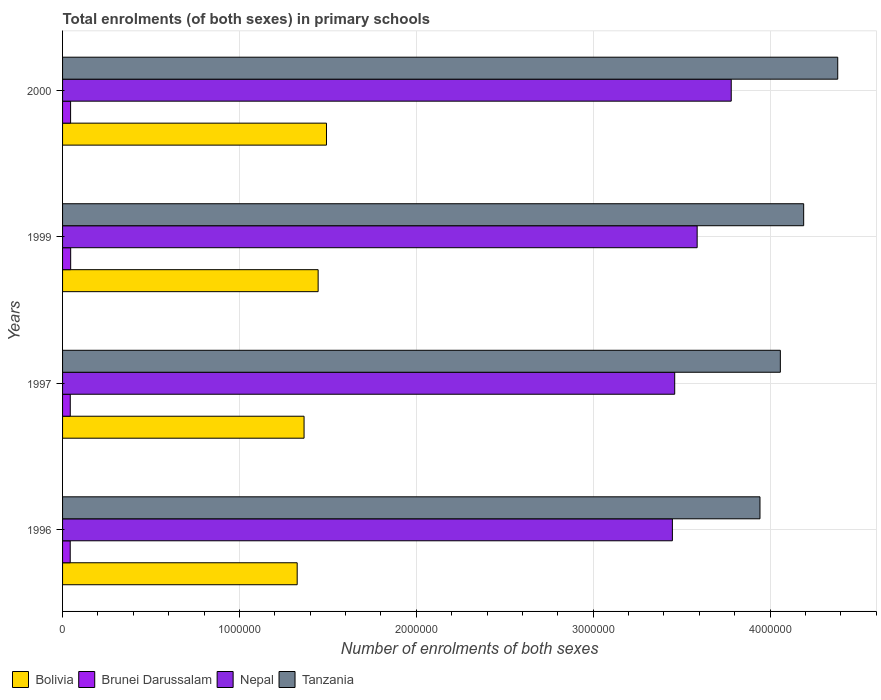How many bars are there on the 2nd tick from the bottom?
Ensure brevity in your answer.  4. What is the label of the 2nd group of bars from the top?
Keep it short and to the point. 1999. What is the number of enrolments in primary schools in Nepal in 1997?
Give a very brief answer. 3.46e+06. Across all years, what is the maximum number of enrolments in primary schools in Bolivia?
Your answer should be compact. 1.49e+06. Across all years, what is the minimum number of enrolments in primary schools in Nepal?
Ensure brevity in your answer.  3.45e+06. What is the total number of enrolments in primary schools in Nepal in the graph?
Offer a terse response. 1.43e+07. What is the difference between the number of enrolments in primary schools in Brunei Darussalam in 1996 and that in 1999?
Your answer should be very brief. -2536. What is the difference between the number of enrolments in primary schools in Brunei Darussalam in 1996 and the number of enrolments in primary schools in Bolivia in 1997?
Your response must be concise. -1.32e+06. What is the average number of enrolments in primary schools in Nepal per year?
Provide a succinct answer. 3.57e+06. In the year 1996, what is the difference between the number of enrolments in primary schools in Nepal and number of enrolments in primary schools in Bolivia?
Offer a very short reply. 2.12e+06. In how many years, is the number of enrolments in primary schools in Tanzania greater than 4000000 ?
Keep it short and to the point. 3. What is the ratio of the number of enrolments in primary schools in Tanzania in 1997 to that in 2000?
Offer a terse response. 0.93. What is the difference between the highest and the second highest number of enrolments in primary schools in Nepal?
Your answer should be compact. 1.93e+05. What is the difference between the highest and the lowest number of enrolments in primary schools in Nepal?
Provide a short and direct response. 3.33e+05. In how many years, is the number of enrolments in primary schools in Tanzania greater than the average number of enrolments in primary schools in Tanzania taken over all years?
Keep it short and to the point. 2. Is the sum of the number of enrolments in primary schools in Tanzania in 1996 and 2000 greater than the maximum number of enrolments in primary schools in Bolivia across all years?
Ensure brevity in your answer.  Yes. Is it the case that in every year, the sum of the number of enrolments in primary schools in Brunei Darussalam and number of enrolments in primary schools in Nepal is greater than the sum of number of enrolments in primary schools in Bolivia and number of enrolments in primary schools in Tanzania?
Offer a very short reply. Yes. What does the 1st bar from the top in 2000 represents?
Your response must be concise. Tanzania. What does the 3rd bar from the bottom in 1997 represents?
Offer a very short reply. Nepal. Are all the bars in the graph horizontal?
Offer a terse response. Yes. How many years are there in the graph?
Make the answer very short. 4. Are the values on the major ticks of X-axis written in scientific E-notation?
Offer a terse response. No. Does the graph contain grids?
Your answer should be very brief. Yes. Where does the legend appear in the graph?
Provide a short and direct response. Bottom left. How are the legend labels stacked?
Give a very brief answer. Horizontal. What is the title of the graph?
Give a very brief answer. Total enrolments (of both sexes) in primary schools. Does "Small states" appear as one of the legend labels in the graph?
Offer a terse response. No. What is the label or title of the X-axis?
Give a very brief answer. Number of enrolments of both sexes. What is the label or title of the Y-axis?
Make the answer very short. Years. What is the Number of enrolments of both sexes of Bolivia in 1996?
Offer a very short reply. 1.33e+06. What is the Number of enrolments of both sexes of Brunei Darussalam in 1996?
Your response must be concise. 4.33e+04. What is the Number of enrolments of both sexes in Nepal in 1996?
Offer a very short reply. 3.45e+06. What is the Number of enrolments of both sexes of Tanzania in 1996?
Provide a succinct answer. 3.94e+06. What is the Number of enrolments of both sexes of Bolivia in 1997?
Ensure brevity in your answer.  1.37e+06. What is the Number of enrolments of both sexes in Brunei Darussalam in 1997?
Ensure brevity in your answer.  4.35e+04. What is the Number of enrolments of both sexes in Nepal in 1997?
Give a very brief answer. 3.46e+06. What is the Number of enrolments of both sexes in Tanzania in 1997?
Your answer should be compact. 4.06e+06. What is the Number of enrolments of both sexes of Bolivia in 1999?
Offer a terse response. 1.44e+06. What is the Number of enrolments of both sexes of Brunei Darussalam in 1999?
Offer a terse response. 4.58e+04. What is the Number of enrolments of both sexes in Nepal in 1999?
Keep it short and to the point. 3.59e+06. What is the Number of enrolments of both sexes in Tanzania in 1999?
Make the answer very short. 4.19e+06. What is the Number of enrolments of both sexes in Bolivia in 2000?
Keep it short and to the point. 1.49e+06. What is the Number of enrolments of both sexes in Brunei Darussalam in 2000?
Your response must be concise. 4.54e+04. What is the Number of enrolments of both sexes in Nepal in 2000?
Provide a succinct answer. 3.78e+06. What is the Number of enrolments of both sexes in Tanzania in 2000?
Offer a very short reply. 4.38e+06. Across all years, what is the maximum Number of enrolments of both sexes in Bolivia?
Your answer should be very brief. 1.49e+06. Across all years, what is the maximum Number of enrolments of both sexes of Brunei Darussalam?
Ensure brevity in your answer.  4.58e+04. Across all years, what is the maximum Number of enrolments of both sexes in Nepal?
Keep it short and to the point. 3.78e+06. Across all years, what is the maximum Number of enrolments of both sexes in Tanzania?
Your answer should be very brief. 4.38e+06. Across all years, what is the minimum Number of enrolments of both sexes of Bolivia?
Provide a short and direct response. 1.33e+06. Across all years, what is the minimum Number of enrolments of both sexes of Brunei Darussalam?
Ensure brevity in your answer.  4.33e+04. Across all years, what is the minimum Number of enrolments of both sexes of Nepal?
Provide a succinct answer. 3.45e+06. Across all years, what is the minimum Number of enrolments of both sexes of Tanzania?
Ensure brevity in your answer.  3.94e+06. What is the total Number of enrolments of both sexes of Bolivia in the graph?
Provide a succinct answer. 5.63e+06. What is the total Number of enrolments of both sexes in Brunei Darussalam in the graph?
Your answer should be very brief. 1.78e+05. What is the total Number of enrolments of both sexes of Nepal in the graph?
Offer a very short reply. 1.43e+07. What is the total Number of enrolments of both sexes in Tanzania in the graph?
Keep it short and to the point. 1.66e+07. What is the difference between the Number of enrolments of both sexes of Bolivia in 1996 and that in 1997?
Offer a terse response. -3.89e+04. What is the difference between the Number of enrolments of both sexes of Brunei Darussalam in 1996 and that in 1997?
Keep it short and to the point. -249. What is the difference between the Number of enrolments of both sexes in Nepal in 1996 and that in 1997?
Provide a succinct answer. -1.31e+04. What is the difference between the Number of enrolments of both sexes in Tanzania in 1996 and that in 1997?
Your answer should be very brief. -1.15e+05. What is the difference between the Number of enrolments of both sexes of Bolivia in 1996 and that in 1999?
Your answer should be very brief. -1.18e+05. What is the difference between the Number of enrolments of both sexes of Brunei Darussalam in 1996 and that in 1999?
Your answer should be compact. -2536. What is the difference between the Number of enrolments of both sexes of Nepal in 1996 and that in 1999?
Offer a terse response. -1.40e+05. What is the difference between the Number of enrolments of both sexes of Tanzania in 1996 and that in 1999?
Offer a very short reply. -2.47e+05. What is the difference between the Number of enrolments of both sexes in Bolivia in 1996 and that in 2000?
Keep it short and to the point. -1.66e+05. What is the difference between the Number of enrolments of both sexes in Brunei Darussalam in 1996 and that in 2000?
Your answer should be compact. -2137. What is the difference between the Number of enrolments of both sexes of Nepal in 1996 and that in 2000?
Keep it short and to the point. -3.33e+05. What is the difference between the Number of enrolments of both sexes of Tanzania in 1996 and that in 2000?
Offer a terse response. -4.40e+05. What is the difference between the Number of enrolments of both sexes in Bolivia in 1997 and that in 1999?
Your answer should be compact. -7.96e+04. What is the difference between the Number of enrolments of both sexes of Brunei Darussalam in 1997 and that in 1999?
Your response must be concise. -2287. What is the difference between the Number of enrolments of both sexes of Nepal in 1997 and that in 1999?
Keep it short and to the point. -1.27e+05. What is the difference between the Number of enrolments of both sexes in Tanzania in 1997 and that in 1999?
Ensure brevity in your answer.  -1.32e+05. What is the difference between the Number of enrolments of both sexes in Bolivia in 1997 and that in 2000?
Your answer should be compact. -1.27e+05. What is the difference between the Number of enrolments of both sexes of Brunei Darussalam in 1997 and that in 2000?
Offer a very short reply. -1888. What is the difference between the Number of enrolments of both sexes in Nepal in 1997 and that in 2000?
Make the answer very short. -3.20e+05. What is the difference between the Number of enrolments of both sexes in Tanzania in 1997 and that in 2000?
Give a very brief answer. -3.24e+05. What is the difference between the Number of enrolments of both sexes in Bolivia in 1999 and that in 2000?
Your answer should be very brief. -4.71e+04. What is the difference between the Number of enrolments of both sexes of Brunei Darussalam in 1999 and that in 2000?
Your answer should be very brief. 399. What is the difference between the Number of enrolments of both sexes in Nepal in 1999 and that in 2000?
Keep it short and to the point. -1.93e+05. What is the difference between the Number of enrolments of both sexes of Tanzania in 1999 and that in 2000?
Provide a succinct answer. -1.93e+05. What is the difference between the Number of enrolments of both sexes of Bolivia in 1996 and the Number of enrolments of both sexes of Brunei Darussalam in 1997?
Give a very brief answer. 1.28e+06. What is the difference between the Number of enrolments of both sexes of Bolivia in 1996 and the Number of enrolments of both sexes of Nepal in 1997?
Make the answer very short. -2.13e+06. What is the difference between the Number of enrolments of both sexes of Bolivia in 1996 and the Number of enrolments of both sexes of Tanzania in 1997?
Make the answer very short. -2.73e+06. What is the difference between the Number of enrolments of both sexes of Brunei Darussalam in 1996 and the Number of enrolments of both sexes of Nepal in 1997?
Offer a terse response. -3.42e+06. What is the difference between the Number of enrolments of both sexes in Brunei Darussalam in 1996 and the Number of enrolments of both sexes in Tanzania in 1997?
Provide a succinct answer. -4.01e+06. What is the difference between the Number of enrolments of both sexes in Nepal in 1996 and the Number of enrolments of both sexes in Tanzania in 1997?
Provide a succinct answer. -6.10e+05. What is the difference between the Number of enrolments of both sexes of Bolivia in 1996 and the Number of enrolments of both sexes of Brunei Darussalam in 1999?
Offer a very short reply. 1.28e+06. What is the difference between the Number of enrolments of both sexes of Bolivia in 1996 and the Number of enrolments of both sexes of Nepal in 1999?
Your response must be concise. -2.26e+06. What is the difference between the Number of enrolments of both sexes in Bolivia in 1996 and the Number of enrolments of both sexes in Tanzania in 1999?
Provide a succinct answer. -2.86e+06. What is the difference between the Number of enrolments of both sexes of Brunei Darussalam in 1996 and the Number of enrolments of both sexes of Nepal in 1999?
Keep it short and to the point. -3.54e+06. What is the difference between the Number of enrolments of both sexes in Brunei Darussalam in 1996 and the Number of enrolments of both sexes in Tanzania in 1999?
Your answer should be very brief. -4.15e+06. What is the difference between the Number of enrolments of both sexes of Nepal in 1996 and the Number of enrolments of both sexes of Tanzania in 1999?
Your answer should be very brief. -7.42e+05. What is the difference between the Number of enrolments of both sexes in Bolivia in 1996 and the Number of enrolments of both sexes in Brunei Darussalam in 2000?
Your answer should be compact. 1.28e+06. What is the difference between the Number of enrolments of both sexes of Bolivia in 1996 and the Number of enrolments of both sexes of Nepal in 2000?
Keep it short and to the point. -2.45e+06. What is the difference between the Number of enrolments of both sexes of Bolivia in 1996 and the Number of enrolments of both sexes of Tanzania in 2000?
Ensure brevity in your answer.  -3.06e+06. What is the difference between the Number of enrolments of both sexes in Brunei Darussalam in 1996 and the Number of enrolments of both sexes in Nepal in 2000?
Provide a succinct answer. -3.74e+06. What is the difference between the Number of enrolments of both sexes in Brunei Darussalam in 1996 and the Number of enrolments of both sexes in Tanzania in 2000?
Provide a succinct answer. -4.34e+06. What is the difference between the Number of enrolments of both sexes in Nepal in 1996 and the Number of enrolments of both sexes in Tanzania in 2000?
Make the answer very short. -9.35e+05. What is the difference between the Number of enrolments of both sexes in Bolivia in 1997 and the Number of enrolments of both sexes in Brunei Darussalam in 1999?
Your answer should be very brief. 1.32e+06. What is the difference between the Number of enrolments of both sexes in Bolivia in 1997 and the Number of enrolments of both sexes in Nepal in 1999?
Make the answer very short. -2.22e+06. What is the difference between the Number of enrolments of both sexes in Bolivia in 1997 and the Number of enrolments of both sexes in Tanzania in 1999?
Your response must be concise. -2.82e+06. What is the difference between the Number of enrolments of both sexes in Brunei Darussalam in 1997 and the Number of enrolments of both sexes in Nepal in 1999?
Give a very brief answer. -3.54e+06. What is the difference between the Number of enrolments of both sexes in Brunei Darussalam in 1997 and the Number of enrolments of both sexes in Tanzania in 1999?
Give a very brief answer. -4.15e+06. What is the difference between the Number of enrolments of both sexes of Nepal in 1997 and the Number of enrolments of both sexes of Tanzania in 1999?
Keep it short and to the point. -7.29e+05. What is the difference between the Number of enrolments of both sexes of Bolivia in 1997 and the Number of enrolments of both sexes of Brunei Darussalam in 2000?
Offer a terse response. 1.32e+06. What is the difference between the Number of enrolments of both sexes of Bolivia in 1997 and the Number of enrolments of both sexes of Nepal in 2000?
Give a very brief answer. -2.41e+06. What is the difference between the Number of enrolments of both sexes of Bolivia in 1997 and the Number of enrolments of both sexes of Tanzania in 2000?
Keep it short and to the point. -3.02e+06. What is the difference between the Number of enrolments of both sexes of Brunei Darussalam in 1997 and the Number of enrolments of both sexes of Nepal in 2000?
Your response must be concise. -3.74e+06. What is the difference between the Number of enrolments of both sexes of Brunei Darussalam in 1997 and the Number of enrolments of both sexes of Tanzania in 2000?
Give a very brief answer. -4.34e+06. What is the difference between the Number of enrolments of both sexes in Nepal in 1997 and the Number of enrolments of both sexes in Tanzania in 2000?
Provide a short and direct response. -9.22e+05. What is the difference between the Number of enrolments of both sexes in Bolivia in 1999 and the Number of enrolments of both sexes in Brunei Darussalam in 2000?
Provide a succinct answer. 1.40e+06. What is the difference between the Number of enrolments of both sexes of Bolivia in 1999 and the Number of enrolments of both sexes of Nepal in 2000?
Provide a succinct answer. -2.34e+06. What is the difference between the Number of enrolments of both sexes of Bolivia in 1999 and the Number of enrolments of both sexes of Tanzania in 2000?
Offer a very short reply. -2.94e+06. What is the difference between the Number of enrolments of both sexes in Brunei Darussalam in 1999 and the Number of enrolments of both sexes in Nepal in 2000?
Ensure brevity in your answer.  -3.73e+06. What is the difference between the Number of enrolments of both sexes of Brunei Darussalam in 1999 and the Number of enrolments of both sexes of Tanzania in 2000?
Offer a terse response. -4.34e+06. What is the difference between the Number of enrolments of both sexes of Nepal in 1999 and the Number of enrolments of both sexes of Tanzania in 2000?
Make the answer very short. -7.95e+05. What is the average Number of enrolments of both sexes of Bolivia per year?
Your response must be concise. 1.41e+06. What is the average Number of enrolments of both sexes of Brunei Darussalam per year?
Provide a succinct answer. 4.45e+04. What is the average Number of enrolments of both sexes of Nepal per year?
Your answer should be very brief. 3.57e+06. What is the average Number of enrolments of both sexes of Tanzania per year?
Offer a very short reply. 4.14e+06. In the year 1996, what is the difference between the Number of enrolments of both sexes of Bolivia and Number of enrolments of both sexes of Brunei Darussalam?
Your answer should be compact. 1.28e+06. In the year 1996, what is the difference between the Number of enrolments of both sexes in Bolivia and Number of enrolments of both sexes in Nepal?
Provide a short and direct response. -2.12e+06. In the year 1996, what is the difference between the Number of enrolments of both sexes of Bolivia and Number of enrolments of both sexes of Tanzania?
Your answer should be very brief. -2.62e+06. In the year 1996, what is the difference between the Number of enrolments of both sexes in Brunei Darussalam and Number of enrolments of both sexes in Nepal?
Provide a succinct answer. -3.40e+06. In the year 1996, what is the difference between the Number of enrolments of both sexes in Brunei Darussalam and Number of enrolments of both sexes in Tanzania?
Your answer should be compact. -3.90e+06. In the year 1996, what is the difference between the Number of enrolments of both sexes of Nepal and Number of enrolments of both sexes of Tanzania?
Provide a succinct answer. -4.95e+05. In the year 1997, what is the difference between the Number of enrolments of both sexes of Bolivia and Number of enrolments of both sexes of Brunei Darussalam?
Your answer should be very brief. 1.32e+06. In the year 1997, what is the difference between the Number of enrolments of both sexes in Bolivia and Number of enrolments of both sexes in Nepal?
Your answer should be very brief. -2.10e+06. In the year 1997, what is the difference between the Number of enrolments of both sexes in Bolivia and Number of enrolments of both sexes in Tanzania?
Your response must be concise. -2.69e+06. In the year 1997, what is the difference between the Number of enrolments of both sexes of Brunei Darussalam and Number of enrolments of both sexes of Nepal?
Your answer should be very brief. -3.42e+06. In the year 1997, what is the difference between the Number of enrolments of both sexes in Brunei Darussalam and Number of enrolments of both sexes in Tanzania?
Provide a short and direct response. -4.01e+06. In the year 1997, what is the difference between the Number of enrolments of both sexes in Nepal and Number of enrolments of both sexes in Tanzania?
Provide a short and direct response. -5.97e+05. In the year 1999, what is the difference between the Number of enrolments of both sexes in Bolivia and Number of enrolments of both sexes in Brunei Darussalam?
Ensure brevity in your answer.  1.40e+06. In the year 1999, what is the difference between the Number of enrolments of both sexes of Bolivia and Number of enrolments of both sexes of Nepal?
Provide a succinct answer. -2.14e+06. In the year 1999, what is the difference between the Number of enrolments of both sexes in Bolivia and Number of enrolments of both sexes in Tanzania?
Ensure brevity in your answer.  -2.74e+06. In the year 1999, what is the difference between the Number of enrolments of both sexes in Brunei Darussalam and Number of enrolments of both sexes in Nepal?
Ensure brevity in your answer.  -3.54e+06. In the year 1999, what is the difference between the Number of enrolments of both sexes of Brunei Darussalam and Number of enrolments of both sexes of Tanzania?
Ensure brevity in your answer.  -4.14e+06. In the year 1999, what is the difference between the Number of enrolments of both sexes of Nepal and Number of enrolments of both sexes of Tanzania?
Your answer should be very brief. -6.02e+05. In the year 2000, what is the difference between the Number of enrolments of both sexes of Bolivia and Number of enrolments of both sexes of Brunei Darussalam?
Ensure brevity in your answer.  1.45e+06. In the year 2000, what is the difference between the Number of enrolments of both sexes in Bolivia and Number of enrolments of both sexes in Nepal?
Keep it short and to the point. -2.29e+06. In the year 2000, what is the difference between the Number of enrolments of both sexes of Bolivia and Number of enrolments of both sexes of Tanzania?
Keep it short and to the point. -2.89e+06. In the year 2000, what is the difference between the Number of enrolments of both sexes in Brunei Darussalam and Number of enrolments of both sexes in Nepal?
Your response must be concise. -3.73e+06. In the year 2000, what is the difference between the Number of enrolments of both sexes of Brunei Darussalam and Number of enrolments of both sexes of Tanzania?
Give a very brief answer. -4.34e+06. In the year 2000, what is the difference between the Number of enrolments of both sexes in Nepal and Number of enrolments of both sexes in Tanzania?
Your answer should be compact. -6.02e+05. What is the ratio of the Number of enrolments of both sexes of Bolivia in 1996 to that in 1997?
Your response must be concise. 0.97. What is the ratio of the Number of enrolments of both sexes of Tanzania in 1996 to that in 1997?
Provide a succinct answer. 0.97. What is the ratio of the Number of enrolments of both sexes in Bolivia in 1996 to that in 1999?
Make the answer very short. 0.92. What is the ratio of the Number of enrolments of both sexes of Brunei Darussalam in 1996 to that in 1999?
Your answer should be very brief. 0.94. What is the ratio of the Number of enrolments of both sexes of Tanzania in 1996 to that in 1999?
Your answer should be compact. 0.94. What is the ratio of the Number of enrolments of both sexes in Bolivia in 1996 to that in 2000?
Give a very brief answer. 0.89. What is the ratio of the Number of enrolments of both sexes of Brunei Darussalam in 1996 to that in 2000?
Offer a very short reply. 0.95. What is the ratio of the Number of enrolments of both sexes in Nepal in 1996 to that in 2000?
Keep it short and to the point. 0.91. What is the ratio of the Number of enrolments of both sexes of Tanzania in 1996 to that in 2000?
Provide a succinct answer. 0.9. What is the ratio of the Number of enrolments of both sexes in Bolivia in 1997 to that in 1999?
Make the answer very short. 0.94. What is the ratio of the Number of enrolments of both sexes of Brunei Darussalam in 1997 to that in 1999?
Provide a succinct answer. 0.95. What is the ratio of the Number of enrolments of both sexes in Nepal in 1997 to that in 1999?
Provide a succinct answer. 0.96. What is the ratio of the Number of enrolments of both sexes in Tanzania in 1997 to that in 1999?
Offer a very short reply. 0.97. What is the ratio of the Number of enrolments of both sexes of Bolivia in 1997 to that in 2000?
Provide a succinct answer. 0.92. What is the ratio of the Number of enrolments of both sexes of Brunei Darussalam in 1997 to that in 2000?
Keep it short and to the point. 0.96. What is the ratio of the Number of enrolments of both sexes in Nepal in 1997 to that in 2000?
Your response must be concise. 0.92. What is the ratio of the Number of enrolments of both sexes of Tanzania in 1997 to that in 2000?
Provide a short and direct response. 0.93. What is the ratio of the Number of enrolments of both sexes in Bolivia in 1999 to that in 2000?
Give a very brief answer. 0.97. What is the ratio of the Number of enrolments of both sexes in Brunei Darussalam in 1999 to that in 2000?
Provide a short and direct response. 1.01. What is the ratio of the Number of enrolments of both sexes of Nepal in 1999 to that in 2000?
Ensure brevity in your answer.  0.95. What is the ratio of the Number of enrolments of both sexes of Tanzania in 1999 to that in 2000?
Make the answer very short. 0.96. What is the difference between the highest and the second highest Number of enrolments of both sexes in Bolivia?
Your response must be concise. 4.71e+04. What is the difference between the highest and the second highest Number of enrolments of both sexes of Brunei Darussalam?
Provide a short and direct response. 399. What is the difference between the highest and the second highest Number of enrolments of both sexes of Nepal?
Ensure brevity in your answer.  1.93e+05. What is the difference between the highest and the second highest Number of enrolments of both sexes of Tanzania?
Give a very brief answer. 1.93e+05. What is the difference between the highest and the lowest Number of enrolments of both sexes in Bolivia?
Give a very brief answer. 1.66e+05. What is the difference between the highest and the lowest Number of enrolments of both sexes of Brunei Darussalam?
Make the answer very short. 2536. What is the difference between the highest and the lowest Number of enrolments of both sexes in Nepal?
Make the answer very short. 3.33e+05. What is the difference between the highest and the lowest Number of enrolments of both sexes of Tanzania?
Offer a very short reply. 4.40e+05. 